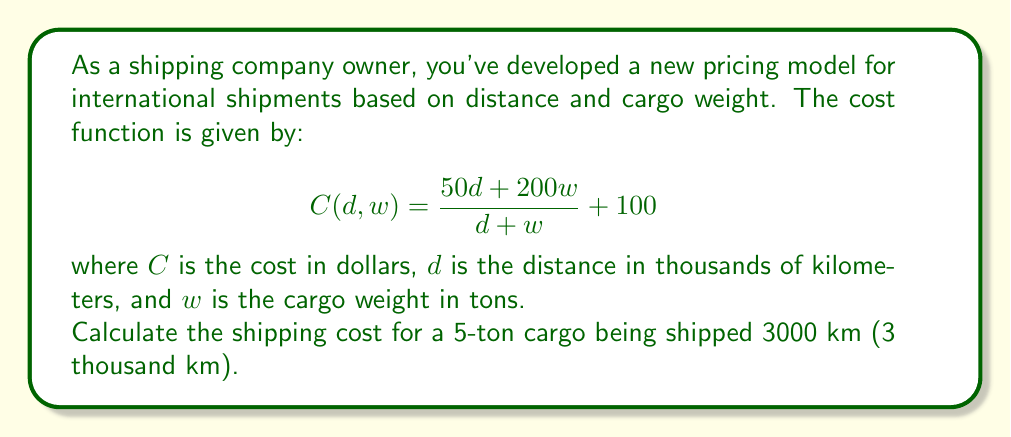Provide a solution to this math problem. Let's approach this step-by-step:

1) We're given the cost function:
   $$C(d,w) = \frac{50d + 200w}{d + w} + 100$$

2) We need to substitute:
   $d = 3$ (3000 km = 3 thousand km)
   $w = 5$ (5 tons)

3) Let's substitute these values into the function:
   $$C(3,5) = \frac{50(3) + 200(5)}{3 + 5} + 100$$

4) Simplify the numerator:
   $$C(3,5) = \frac{150 + 1000}{3 + 5} + 100 = \frac{1150}{8} + 100$$

5) Divide 1150 by 8:
   $$C(3,5) = 143.75 + 100$$

6) Add the final 100:
   $$C(3,5) = 243.75$$

Therefore, the shipping cost for a 5-ton cargo being shipped 3000 km is $243.75.
Answer: $243.75 